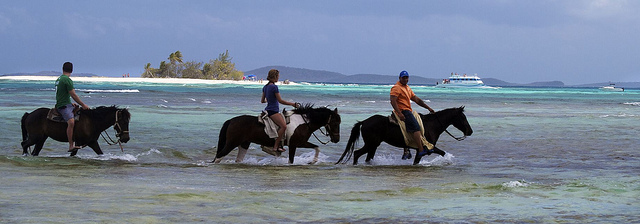Describe the setting of the image. The image depicts a serene beach setting with crystal clear and calm turquoise waters, white sands, and a glimpse of lush greenery in the distance. A leisure boat is on the horizon, suggesting that the location is a popular spot for vacationers seeking the tranquility of a tropical paradise. 